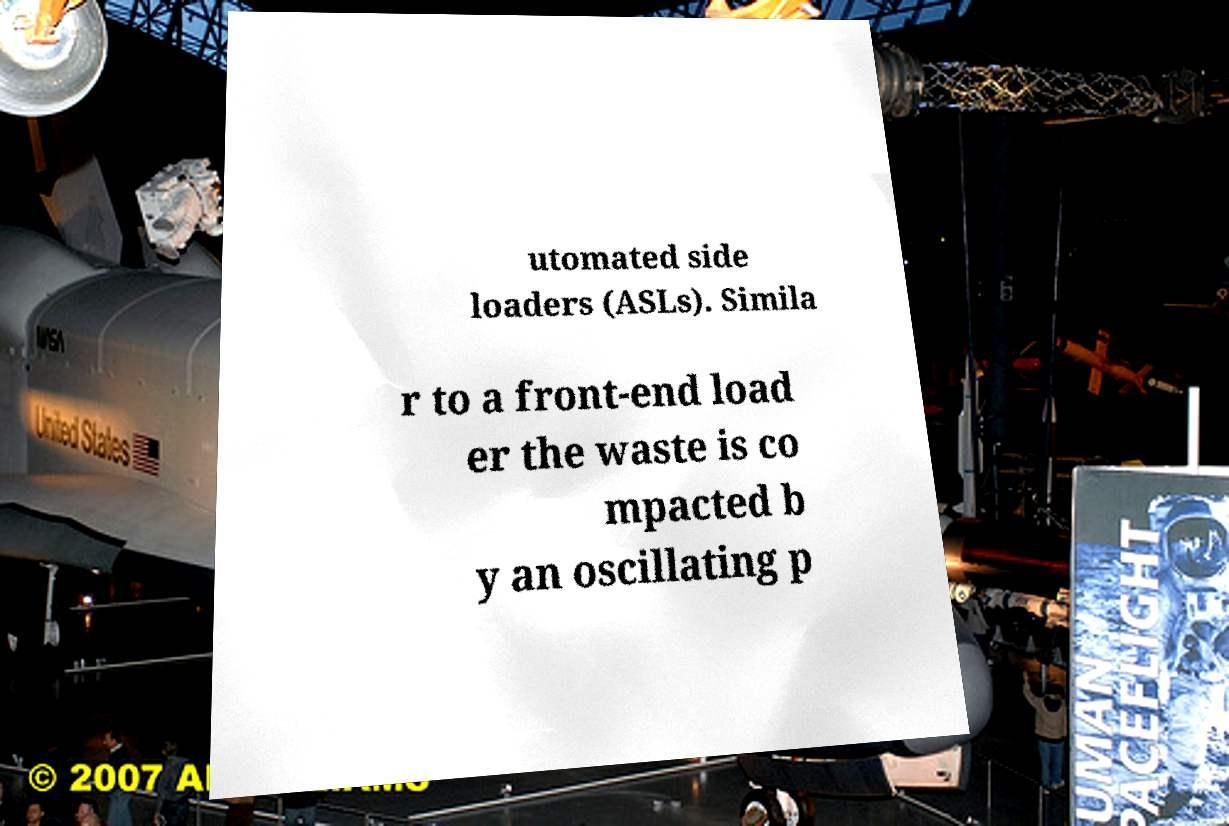Can you read and provide the text displayed in the image?This photo seems to have some interesting text. Can you extract and type it out for me? utomated side loaders (ASLs). Simila r to a front-end load er the waste is co mpacted b y an oscillating p 